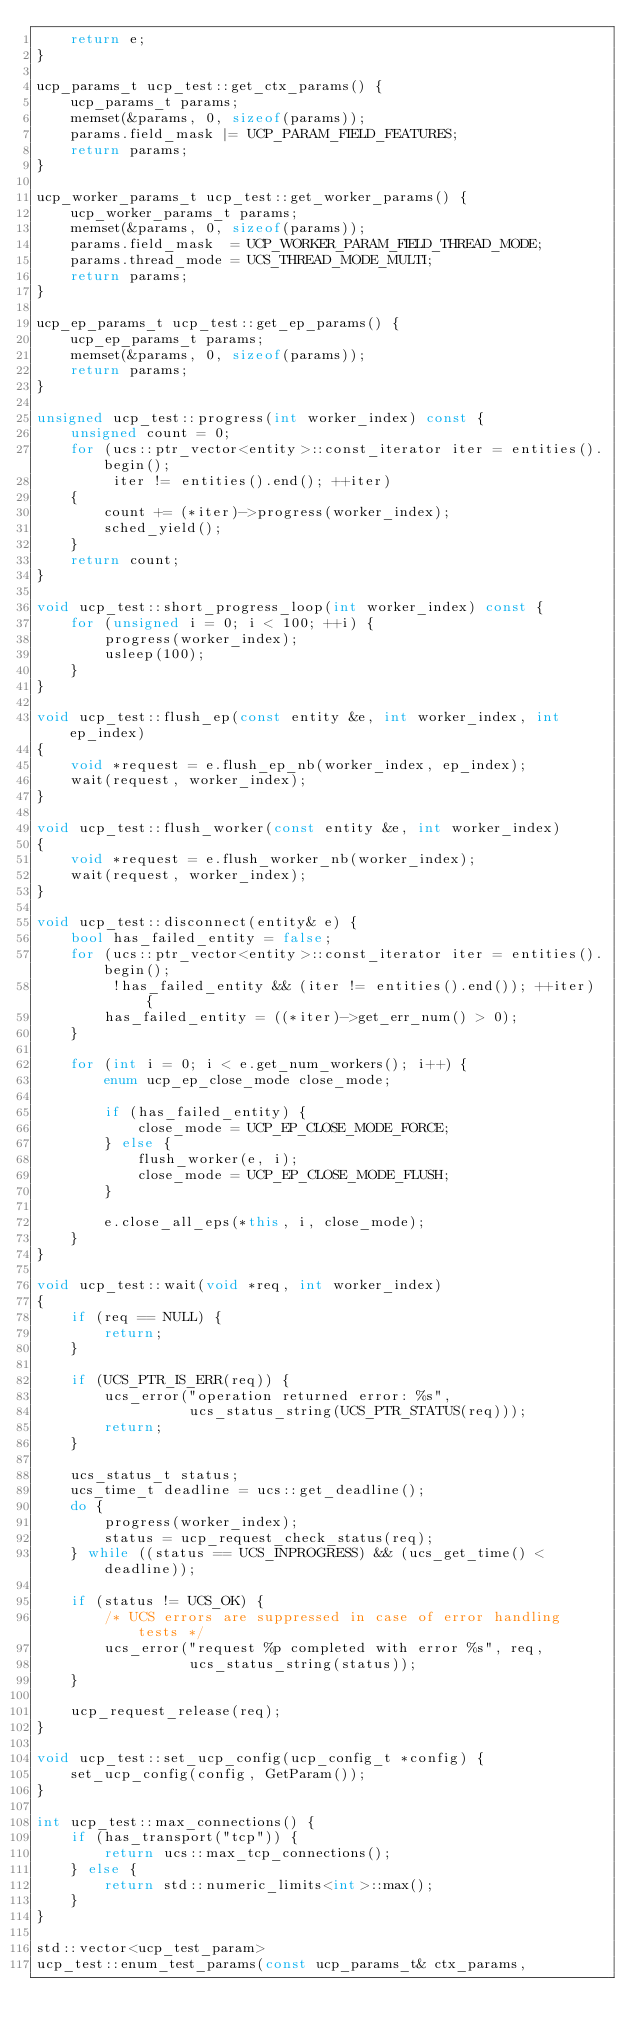Convert code to text. <code><loc_0><loc_0><loc_500><loc_500><_C++_>    return e;
}

ucp_params_t ucp_test::get_ctx_params() {
    ucp_params_t params;
    memset(&params, 0, sizeof(params));
    params.field_mask |= UCP_PARAM_FIELD_FEATURES;
    return params;
}

ucp_worker_params_t ucp_test::get_worker_params() {
    ucp_worker_params_t params;
    memset(&params, 0, sizeof(params));
    params.field_mask  = UCP_WORKER_PARAM_FIELD_THREAD_MODE;
    params.thread_mode = UCS_THREAD_MODE_MULTI;
    return params;
}

ucp_ep_params_t ucp_test::get_ep_params() {
    ucp_ep_params_t params;
    memset(&params, 0, sizeof(params));
    return params;
}

unsigned ucp_test::progress(int worker_index) const {
    unsigned count = 0;
    for (ucs::ptr_vector<entity>::const_iterator iter = entities().begin();
         iter != entities().end(); ++iter)
    {
        count += (*iter)->progress(worker_index);
        sched_yield();
    }
    return count;
}

void ucp_test::short_progress_loop(int worker_index) const {
    for (unsigned i = 0; i < 100; ++i) {
        progress(worker_index);
        usleep(100);
    }
}

void ucp_test::flush_ep(const entity &e, int worker_index, int ep_index)
{
    void *request = e.flush_ep_nb(worker_index, ep_index);
    wait(request, worker_index);
}

void ucp_test::flush_worker(const entity &e, int worker_index)
{
    void *request = e.flush_worker_nb(worker_index);
    wait(request, worker_index);
}

void ucp_test::disconnect(entity& e) {
    bool has_failed_entity = false;
    for (ucs::ptr_vector<entity>::const_iterator iter = entities().begin();
         !has_failed_entity && (iter != entities().end()); ++iter) {
        has_failed_entity = ((*iter)->get_err_num() > 0);
    }

    for (int i = 0; i < e.get_num_workers(); i++) {
        enum ucp_ep_close_mode close_mode;

        if (has_failed_entity) {
            close_mode = UCP_EP_CLOSE_MODE_FORCE;
        } else {
            flush_worker(e, i);
            close_mode = UCP_EP_CLOSE_MODE_FLUSH;
        }

        e.close_all_eps(*this, i, close_mode);
    }
}

void ucp_test::wait(void *req, int worker_index)
{
    if (req == NULL) {
        return;
    }

    if (UCS_PTR_IS_ERR(req)) {
        ucs_error("operation returned error: %s",
                  ucs_status_string(UCS_PTR_STATUS(req)));
        return;
    }

    ucs_status_t status;
    ucs_time_t deadline = ucs::get_deadline();
    do {
        progress(worker_index);
        status = ucp_request_check_status(req);
    } while ((status == UCS_INPROGRESS) && (ucs_get_time() < deadline));

    if (status != UCS_OK) {
        /* UCS errors are suppressed in case of error handling tests */
        ucs_error("request %p completed with error %s", req,
                  ucs_status_string(status));
    }

    ucp_request_release(req);
}

void ucp_test::set_ucp_config(ucp_config_t *config) {
    set_ucp_config(config, GetParam());
}

int ucp_test::max_connections() {
    if (has_transport("tcp")) {
        return ucs::max_tcp_connections();
    } else {
        return std::numeric_limits<int>::max();
    }
}

std::vector<ucp_test_param>
ucp_test::enum_test_params(const ucp_params_t& ctx_params,</code> 